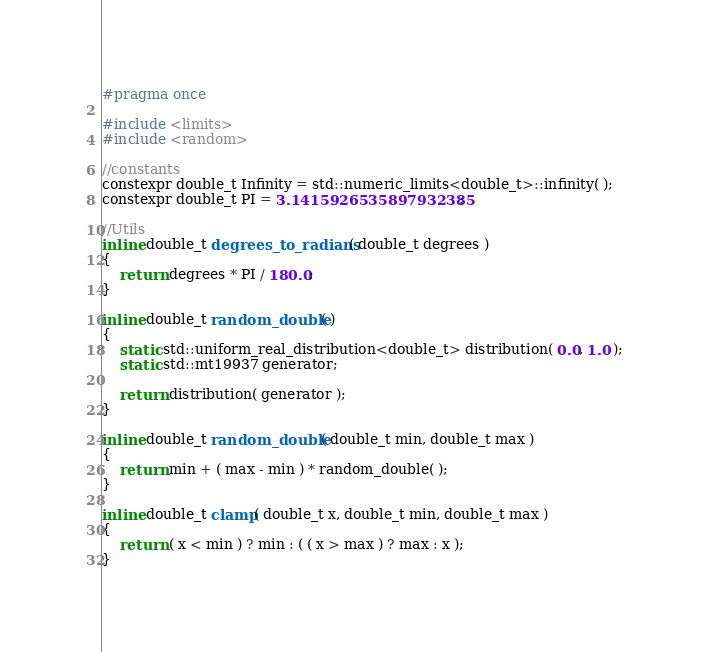Convert code to text. <code><loc_0><loc_0><loc_500><loc_500><_C_>#pragma once

#include <limits>
#include <random>

//constants
constexpr double_t Infinity = std::numeric_limits<double_t>::infinity( );
constexpr double_t PI = 3.1415926535897932385;

//Utils
inline double_t degrees_to_radians( double_t degrees )
{
	return degrees * PI / 180.0;
}

inline double_t random_double( )
{
	static std::uniform_real_distribution<double_t> distribution( 0.0, 1.0 );
	static std::mt19937 generator;

	return distribution( generator );
}

inline double_t random_double( double_t min, double_t max )
{
	return min + ( max - min ) * random_double( );
}

inline double_t clamp( double_t x, double_t min, double_t max )
{
	return ( x < min ) ? min : ( ( x > max ) ? max : x );
}

</code> 